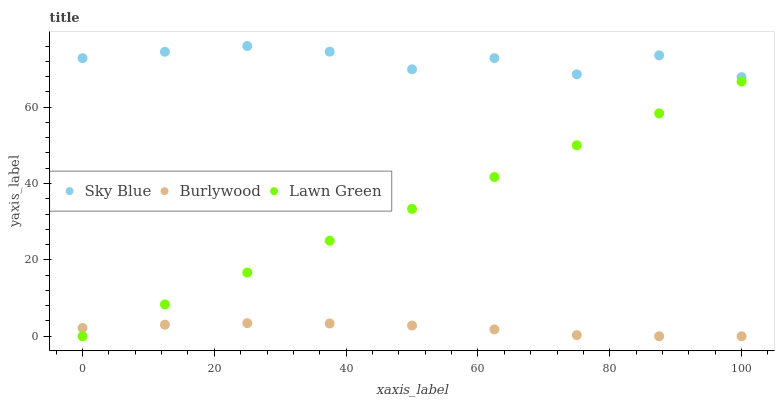Does Burlywood have the minimum area under the curve?
Answer yes or no. Yes. Does Sky Blue have the maximum area under the curve?
Answer yes or no. Yes. Does Lawn Green have the minimum area under the curve?
Answer yes or no. No. Does Lawn Green have the maximum area under the curve?
Answer yes or no. No. Is Lawn Green the smoothest?
Answer yes or no. Yes. Is Sky Blue the roughest?
Answer yes or no. Yes. Is Sky Blue the smoothest?
Answer yes or no. No. Is Lawn Green the roughest?
Answer yes or no. No. Does Burlywood have the lowest value?
Answer yes or no. Yes. Does Sky Blue have the lowest value?
Answer yes or no. No. Does Sky Blue have the highest value?
Answer yes or no. Yes. Does Lawn Green have the highest value?
Answer yes or no. No. Is Lawn Green less than Sky Blue?
Answer yes or no. Yes. Is Sky Blue greater than Lawn Green?
Answer yes or no. Yes. Does Burlywood intersect Lawn Green?
Answer yes or no. Yes. Is Burlywood less than Lawn Green?
Answer yes or no. No. Is Burlywood greater than Lawn Green?
Answer yes or no. No. Does Lawn Green intersect Sky Blue?
Answer yes or no. No. 